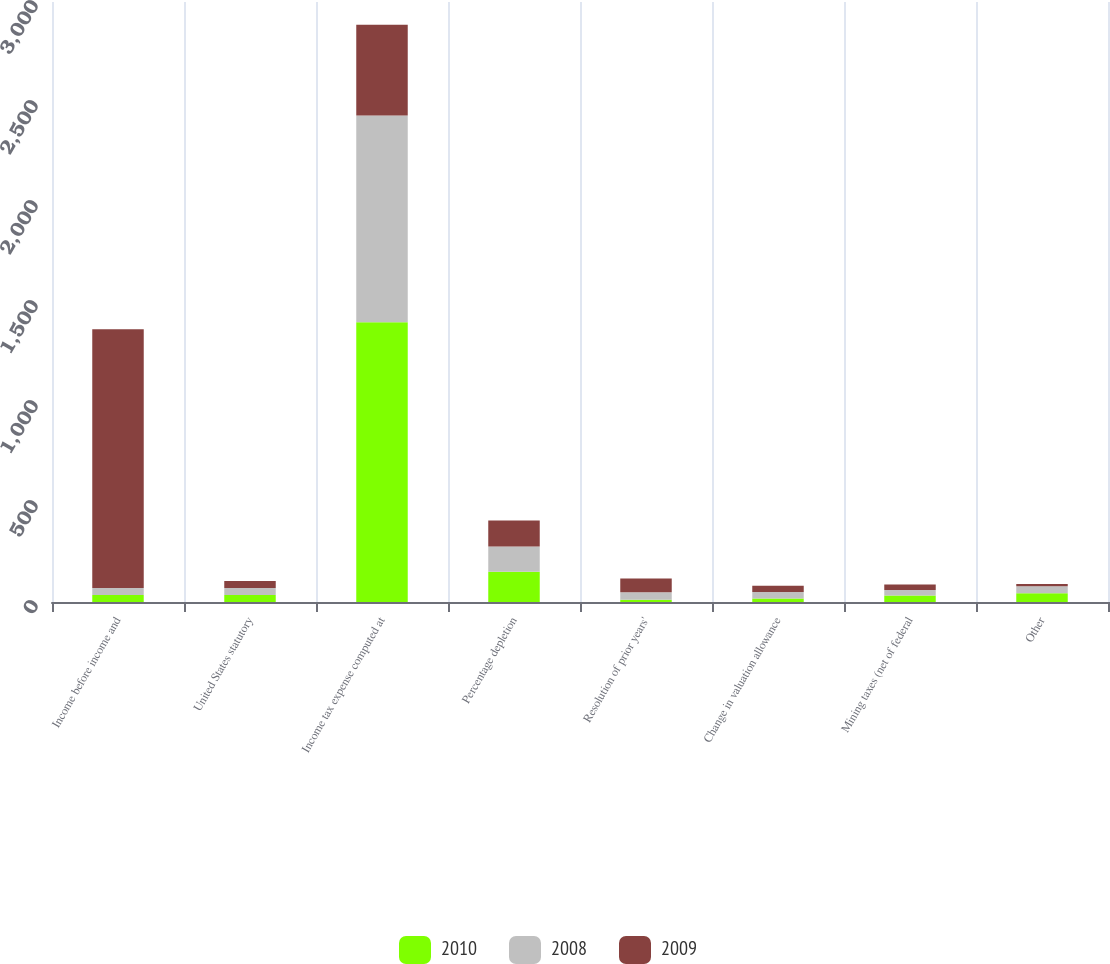Convert chart. <chart><loc_0><loc_0><loc_500><loc_500><stacked_bar_chart><ecel><fcel>Income before income and<fcel>United States statutory<fcel>Income tax expense computed at<fcel>Percentage depletion<fcel>Resolution of prior years'<fcel>Change in valuation allowance<fcel>Mining taxes (net of federal<fcel>Other<nl><fcel>2010<fcel>35<fcel>35<fcel>1399<fcel>151<fcel>11<fcel>18<fcel>33<fcel>44<nl><fcel>2008<fcel>35<fcel>35<fcel>1034<fcel>127<fcel>38<fcel>32<fcel>27<fcel>35<nl><fcel>2009<fcel>1294<fcel>35<fcel>453<fcel>130<fcel>69<fcel>31<fcel>27<fcel>11<nl></chart> 